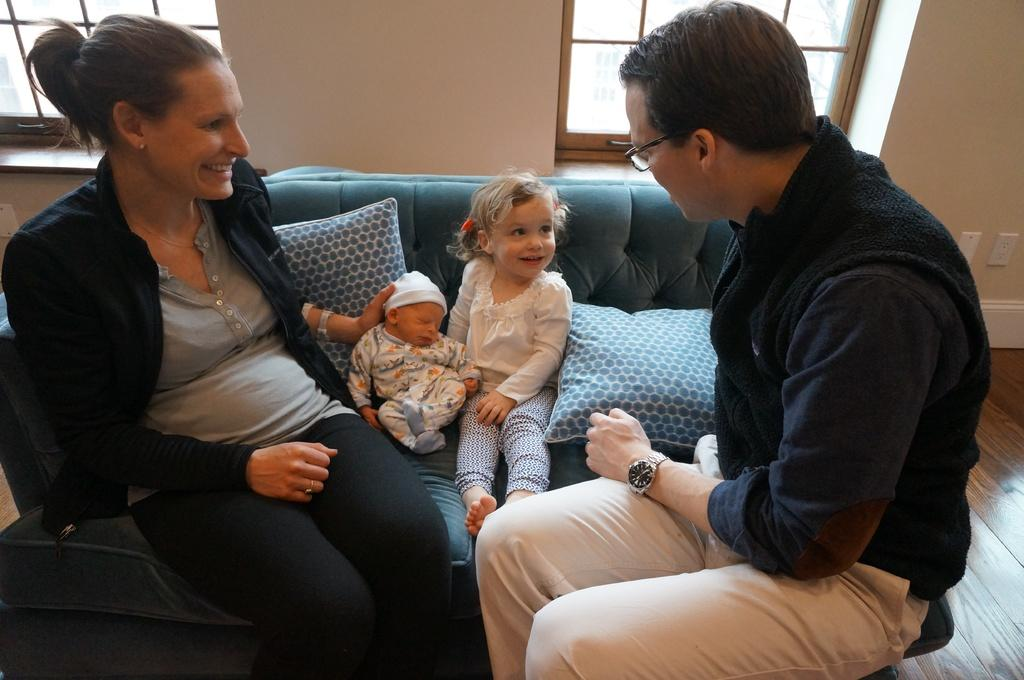How many people are present in the image? There are four people in the image: a lady, a man, and two children. What are the people in the image doing? The lady, man, and children are sitting on a sofa. What can be seen in the background of the image? There is a wall and windows visible in the background of the image. What type of engine can be seen in the image? There is no engine present in the image. How does the division of labor occur among the people in the image? The image does not depict any labor or division of tasks, so this question cannot be answered. 